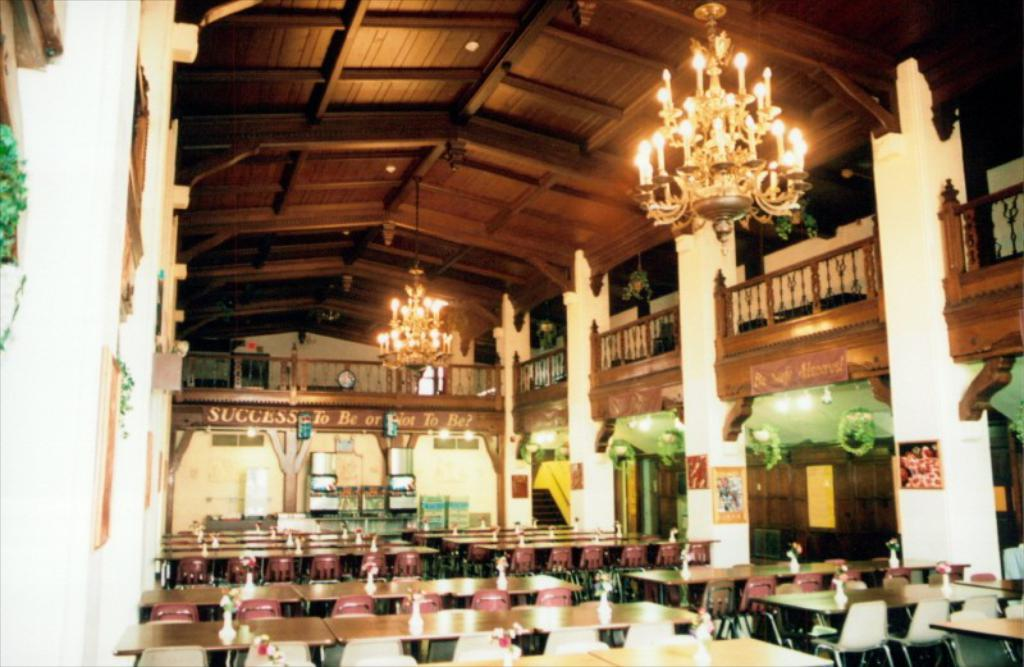What type of furniture is present in the image? There are many chairs and tables in the image. What can be found on top of the tables? There are pots with flowers on the tables. What architectural elements are visible in the image? There are pillars and a fence in the image. What type of lighting is present in the image? There are chandeliers in the image. What type of coil is used to hold the umbrella in the image? There is no umbrella present in the image, so there is no coil to hold it. 